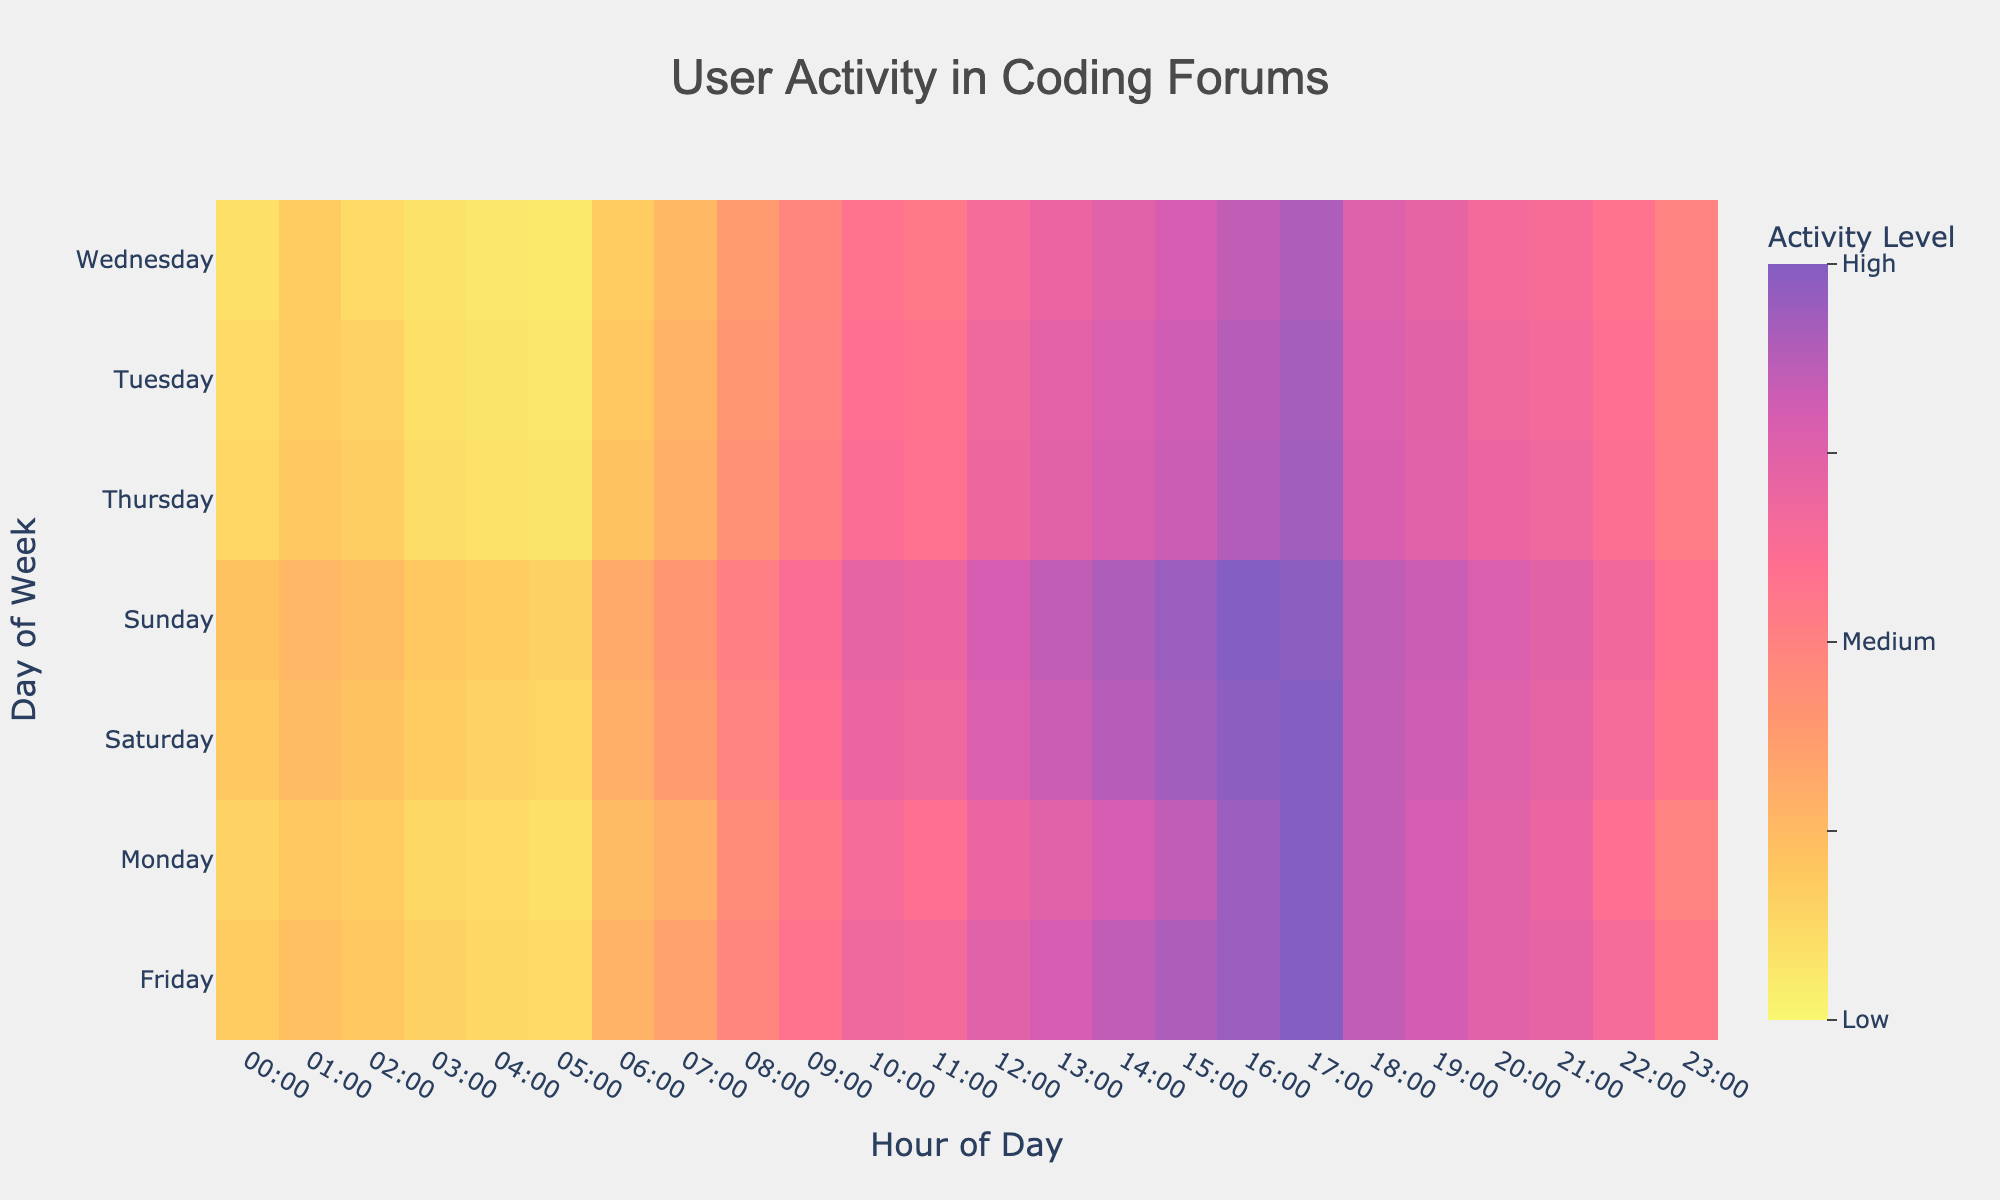What is the title of the heatmap? The title is displayed at the top center of the figure in a larger font and reads "User Activity in Coding Forums".
Answer: User Activity in Coding Forums When is the peak user activity on Monday? To find the peak user activity on Monday, locate the row for Monday and identify the highest value in that row. The highest activity value is 100, which occurs at 17:00.
Answer: 17:00 Which day has the highest overall activity, and what time does it occur? To determine the day with the highest overall activity, look for the highest value across all days and hours. The highest value is 100, and it occurs on multiple days: Monday at 17:00, Friday at 17:00, Saturday at 17:00, and Sunday at 16:00. Therefore, the days are Monday, Friday, Saturday, and Sunday.
Answer: Monday, Friday, Saturday, and Sunday at 17:00, and Sunday at 16:00 What is the average activity level on Thursdays between 09:00 and 12:00? Find the activity values for Thursday between 09:00 and 12:00, which are 52, 62, and 59. Sum these values (52 + 62 + 59 = 173) and then divide by the number of hours (3). The average activity level is 173/3 = 57.67.
Answer: 57.67 How does user activity on Wednesday at 14:00 compare to Tuesday at the same time? To compare user activity, locate the activity values for Wednesday at 14:00 and Tuesday at 14:00. Wednesday has an activity value of 75, while Tuesday has an activity value of 78. Therefore, Tuesday has slightly higher activity.
Answer: Tuesday has higher activity (78 vs 75) What times of the day have the lowest user activity for each weekday? To find the lowest activity times, identify the minimum activity values for each day and their corresponding times. 
  - Monday: 05:00 (10)
  - Tuesday: 05:00 (7)
  - Wednesday: 05:00 (6)
  - Thursday: 05:00 (8)
  - Friday: 05:00 (12)
  - Saturday: 05:00 (14)
  - Sunday: 05:00 (16)
Answer: 05:00 every day At which hour does user activity start to significantly increase on an average weekday? Observing the heatmap's activity values, user activity tends to significantly increase starting at 09:00 across most weekdays, as values rise sharply compared to earlier hours.
Answer: 09:00 